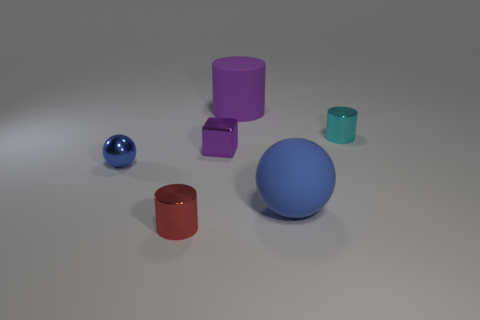Do the small shiny cube and the big rubber thing behind the small purple object have the same color?
Your answer should be compact. Yes. There is a small blue object that is the same material as the tiny red thing; what is its shape?
Your answer should be very brief. Sphere. Do the tiny metallic object that is in front of the matte sphere and the cyan object have the same shape?
Keep it short and to the point. Yes. There is a metal object that is in front of the small blue ball in front of the purple cylinder; what is its size?
Your answer should be very brief. Small. What is the color of the small sphere that is the same material as the cyan cylinder?
Offer a terse response. Blue. What number of blue matte spheres have the same size as the matte cylinder?
Offer a terse response. 1. How many blue things are either small metal things or big objects?
Ensure brevity in your answer.  2. How many objects are either large blue matte balls or small things that are to the right of the red metallic cylinder?
Offer a very short reply. 3. What is the material of the object that is behind the tiny cyan metal cylinder?
Keep it short and to the point. Rubber. What is the shape of the red metallic thing that is the same size as the purple cube?
Ensure brevity in your answer.  Cylinder. 